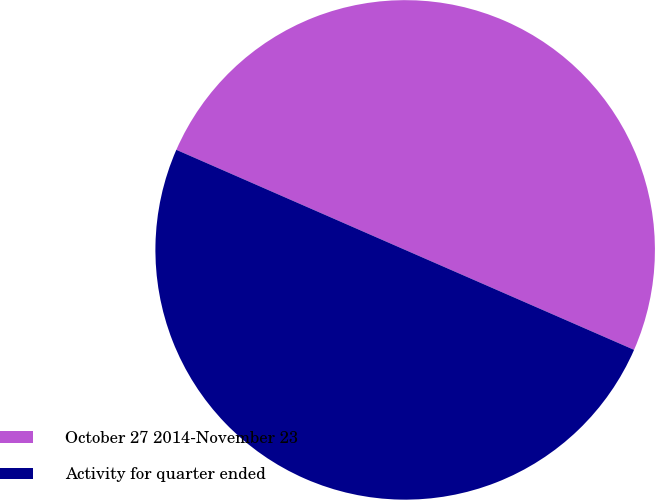Convert chart to OTSL. <chart><loc_0><loc_0><loc_500><loc_500><pie_chart><fcel>October 27 2014-November 23<fcel>Activity for quarter ended<nl><fcel>49.99%<fcel>50.01%<nl></chart> 